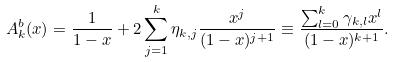<formula> <loc_0><loc_0><loc_500><loc_500>A _ { k } ^ { b } ( x ) = \frac { 1 } { 1 - x } + 2 \sum _ { j = 1 } ^ { k } \eta _ { k , j } \frac { x ^ { j } } { ( 1 - x ) ^ { j + 1 } } \equiv \frac { \sum _ { l = 0 } ^ { k } \gamma _ { k , l } x ^ { l } } { ( 1 - x ) ^ { k + 1 } } .</formula> 